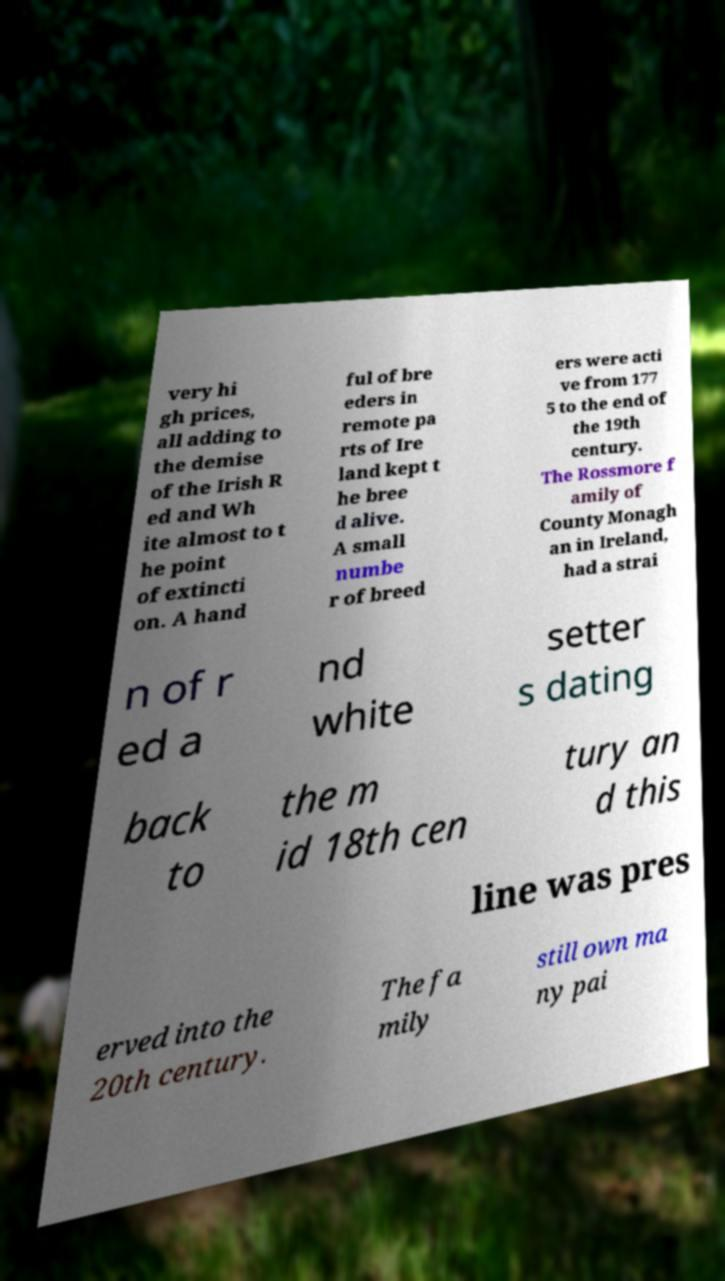There's text embedded in this image that I need extracted. Can you transcribe it verbatim? very hi gh prices, all adding to the demise of the Irish R ed and Wh ite almost to t he point of extincti on. A hand ful of bre eders in remote pa rts of Ire land kept t he bree d alive. A small numbe r of breed ers were acti ve from 177 5 to the end of the 19th century. The Rossmore f amily of County Monagh an in Ireland, had a strai n of r ed a nd white setter s dating back to the m id 18th cen tury an d this line was pres erved into the 20th century. The fa mily still own ma ny pai 